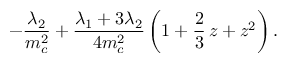Convert formula to latex. <formula><loc_0><loc_0><loc_500><loc_500>- { \frac { \lambda _ { 2 } } { m _ { c } ^ { 2 } } } + { \frac { \lambda _ { 1 } + 3 \lambda _ { 2 } } { 4 m _ { c } ^ { 2 } } } \, \left ( 1 + \frac { 2 } { 3 } \, z + z ^ { 2 } \right ) \, .</formula> 